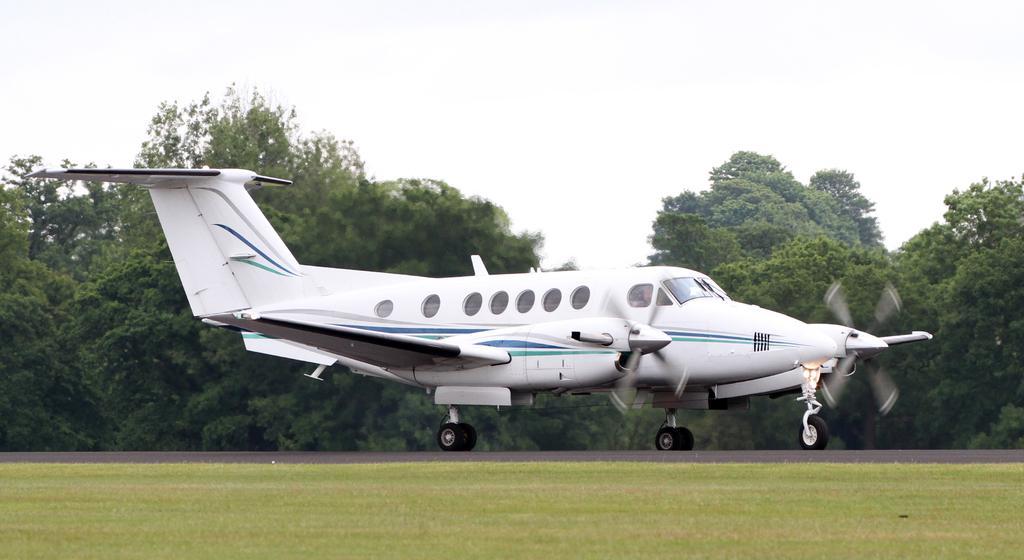In one or two sentences, can you explain what this image depicts? In the image there is a plane on the ground and in the foreground there is grass, in the background there are many trees. 